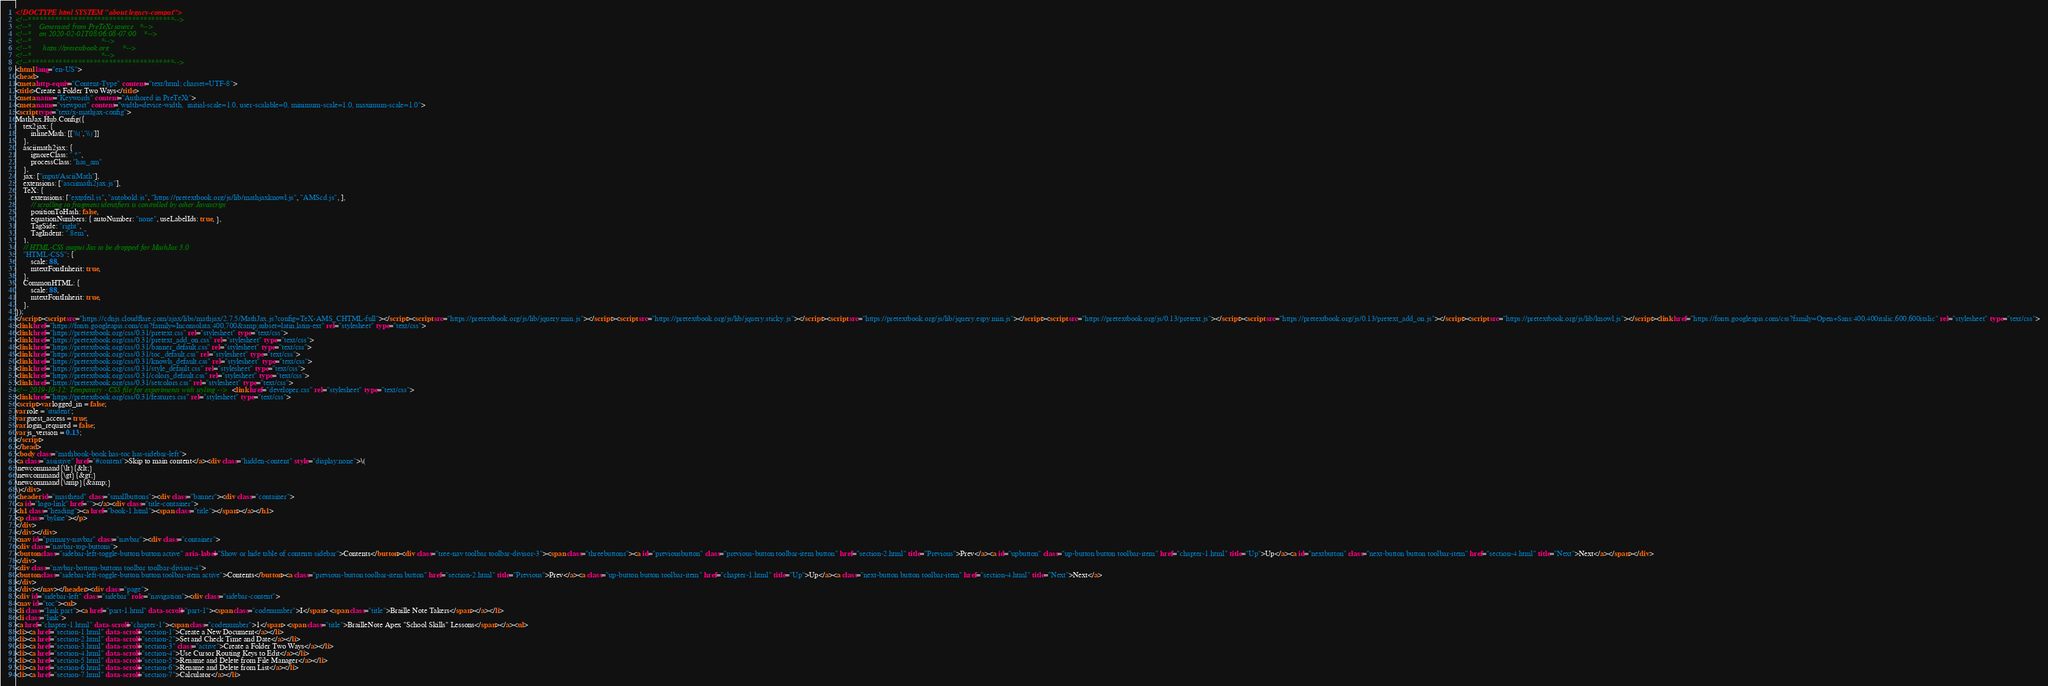<code> <loc_0><loc_0><loc_500><loc_500><_HTML_><!DOCTYPE html SYSTEM "about:legacy-compat">
<!--**************************************-->
<!--*    Generated from PreTeXt source   *-->
<!--*    on 2020-02-01T08:06:08-07:00    *-->
<!--*                                    *-->
<!--*      https://pretextbook.org       *-->
<!--*                                    *-->
<!--**************************************-->
<html lang="en-US">
<head>
<meta http-equiv="Content-Type" content="text/html; charset=UTF-8">
<title>Create a Folder Two Ways</title>
<meta name="Keywords" content="Authored in PreTeXt">
<meta name="viewport" content="width=device-width,  initial-scale=1.0, user-scalable=0, minimum-scale=1.0, maximum-scale=1.0">
<script type="text/x-mathjax-config">
MathJax.Hub.Config({
    tex2jax: {
        inlineMath: [['\\(','\\)']]
    },
    asciimath2jax: {
        ignoreClass: ".*",
        processClass: "has_am"
    },
    jax: ["input/AsciiMath"],
    extensions: ["asciimath2jax.js"],
    TeX: {
        extensions: ["extpfeil.js", "autobold.js", "https://pretextbook.org/js/lib/mathjaxknowl.js", "AMScd.js", ],
        // scrolling to fragment identifiers is controlled by other Javascript
        positionToHash: false,
        equationNumbers: { autoNumber: "none", useLabelIds: true, },
        TagSide: "right",
        TagIndent: ".8em",
    },
    // HTML-CSS output Jax to be dropped for MathJax 3.0
    "HTML-CSS": {
        scale: 88,
        mtextFontInherit: true,
    },
    CommonHTML: {
        scale: 88,
        mtextFontInherit: true,
    },
});
</script><script src="https://cdnjs.cloudflare.com/ajax/libs/mathjax/2.7.5/MathJax.js?config=TeX-AMS_CHTML-full"></script><script src="https://pretextbook.org/js/lib/jquery.min.js"></script><script src="https://pretextbook.org/js/lib/jquery.sticky.js"></script><script src="https://pretextbook.org/js/lib/jquery.espy.min.js"></script><script src="https://pretextbook.org/js/0.13/pretext.js"></script><script src="https://pretextbook.org/js/0.13/pretext_add_on.js"></script><script src="https://pretextbook.org/js/lib/knowl.js"></script><link href="https://fonts.googleapis.com/css?family=Open+Sans:400,400italic,600,600italic" rel="stylesheet" type="text/css">
<link href="https://fonts.googleapis.com/css?family=Inconsolata:400,700&amp;subset=latin,latin-ext" rel="stylesheet" type="text/css">
<link href="https://pretextbook.org/css/0.31/pretext.css" rel="stylesheet" type="text/css">
<link href="https://pretextbook.org/css/0.31/pretext_add_on.css" rel="stylesheet" type="text/css">
<link href="https://pretextbook.org/css/0.31/banner_default.css" rel="stylesheet" type="text/css">
<link href="https://pretextbook.org/css/0.31/toc_default.css" rel="stylesheet" type="text/css">
<link href="https://pretextbook.org/css/0.31/knowls_default.css" rel="stylesheet" type="text/css">
<link href="https://pretextbook.org/css/0.31/style_default.css" rel="stylesheet" type="text/css">
<link href="https://pretextbook.org/css/0.31/colors_default.css" rel="stylesheet" type="text/css">
<link href="https://pretextbook.org/css/0.31/setcolors.css" rel="stylesheet" type="text/css">
<!-- 2019-10-12: Temporary - CSS file for experiments with styling --><link href="developer.css" rel="stylesheet" type="text/css">
<link href="https://pretextbook.org/css/0.31/features.css" rel="stylesheet" type="text/css">
<script>var logged_in = false;
var role = 'student';
var guest_access = true;
var login_required = false;
var js_version = 0.13;
</script>
</head>
<body class="mathbook-book has-toc has-sidebar-left">
<a class="assistive" href="#content">Skip to main content</a><div class="hidden-content" style="display:none">\(
\newcommand{\lt}{&lt;}
\newcommand{\gt}{&gt;}
\newcommand{\amp}{&amp;}
\)</div>
<header id="masthead" class="smallbuttons"><div class="banner"><div class="container">
<a id="logo-link" href=""></a><div class="title-container">
<h1 class="heading"><a href="book-1.html"><span class="title"></span></a></h1>
<p class="byline"></p>
</div>
</div></div>
<nav id="primary-navbar" class="navbar"><div class="container">
<div class="navbar-top-buttons">
<button class="sidebar-left-toggle-button button active" aria-label="Show or hide table of contents sidebar">Contents</button><div class="tree-nav toolbar toolbar-divisor-3"><span class="threebuttons"><a id="previousbutton" class="previous-button toolbar-item button" href="section-2.html" title="Previous">Prev</a><a id="upbutton" class="up-button button toolbar-item" href="chapter-1.html" title="Up">Up</a><a id="nextbutton" class="next-button button toolbar-item" href="section-4.html" title="Next">Next</a></span></div>
</div>
<div class="navbar-bottom-buttons toolbar toolbar-divisor-4">
<button class="sidebar-left-toggle-button button toolbar-item active">Contents</button><a class="previous-button toolbar-item button" href="section-2.html" title="Previous">Prev</a><a class="up-button button toolbar-item" href="chapter-1.html" title="Up">Up</a><a class="next-button button toolbar-item" href="section-4.html" title="Next">Next</a>
</div>
</div></nav></header><div class="page">
<div id="sidebar-left" class="sidebar" role="navigation"><div class="sidebar-content">
<nav id="toc"><ul>
<li class="link part"><a href="part-1.html" data-scroll="part-1"><span class="codenumber">I</span> <span class="title">Braille Note Takers</span></a></li>
<li class="link">
<a href="chapter-1.html" data-scroll="chapter-1"><span class="codenumber">1</span> <span class="title">BrailleNote Apex "School Skills" Lessons</span></a><ul>
<li><a href="section-1.html" data-scroll="section-1">Create a New Document</a></li>
<li><a href="section-2.html" data-scroll="section-2">Set and Check Time and Date</a></li>
<li><a href="section-3.html" data-scroll="section-3" class="active">Create a Folder Two Ways</a></li>
<li><a href="section-4.html" data-scroll="section-4">Use Cursor Routing Keys to Edit</a></li>
<li><a href="section-5.html" data-scroll="section-5">Rename and Delete from File Manager</a></li>
<li><a href="section-6.html" data-scroll="section-6">Rename and Delete from List</a></li>
<li><a href="section-7.html" data-scroll="section-7">Calculator</a></li></code> 